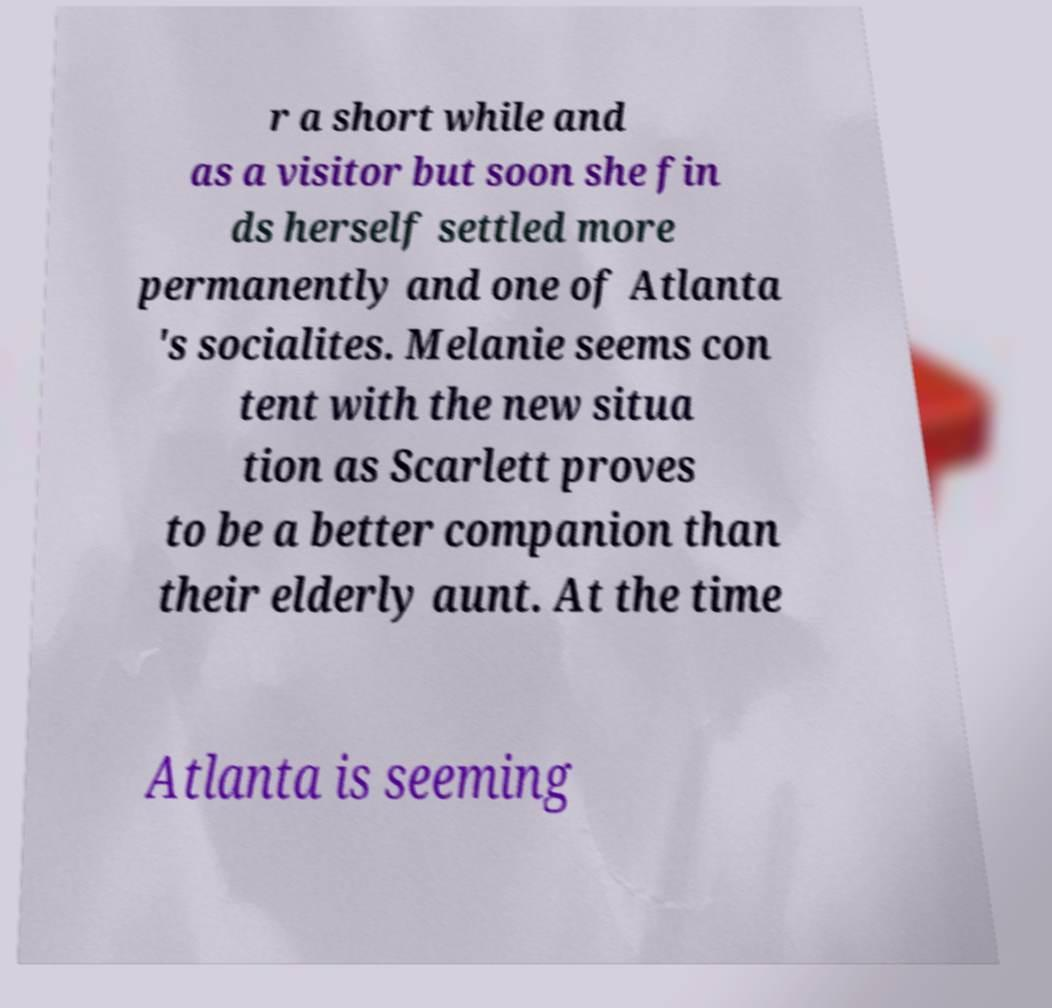There's text embedded in this image that I need extracted. Can you transcribe it verbatim? r a short while and as a visitor but soon she fin ds herself settled more permanently and one of Atlanta 's socialites. Melanie seems con tent with the new situa tion as Scarlett proves to be a better companion than their elderly aunt. At the time Atlanta is seeming 